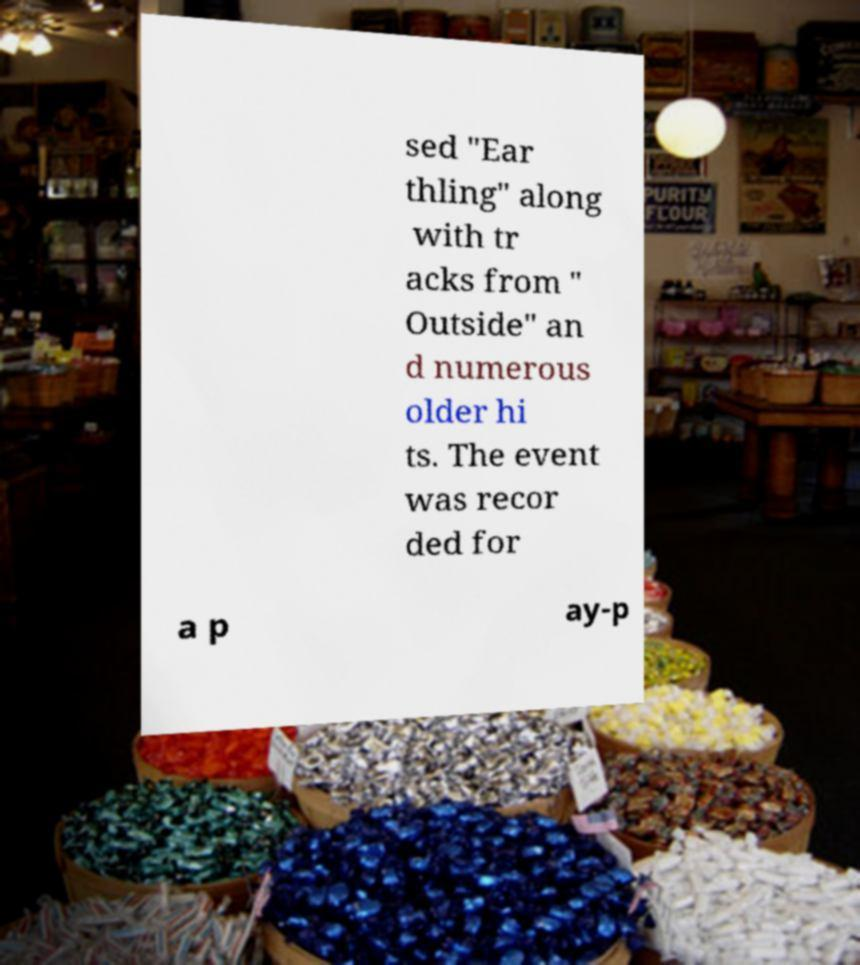Could you assist in decoding the text presented in this image and type it out clearly? sed "Ear thling" along with tr acks from " Outside" an d numerous older hi ts. The event was recor ded for a p ay-p 